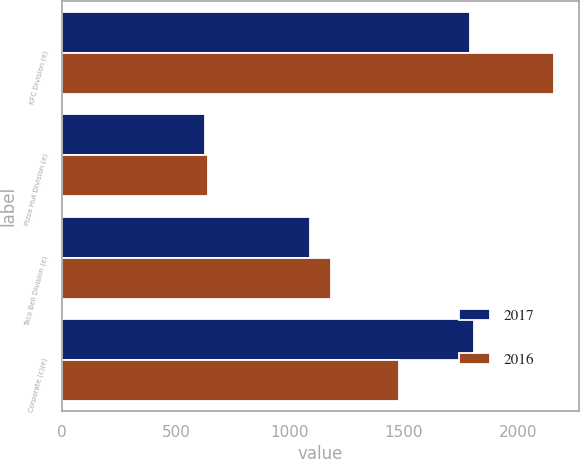Convert chart to OTSL. <chart><loc_0><loc_0><loc_500><loc_500><stacked_bar_chart><ecel><fcel>KFC Division (e)<fcel>Pizza Hut Division (e)<fcel>Taco Bell Division (e)<fcel>Corporate (c)(e)<nl><fcel>2017<fcel>1791<fcel>628<fcel>1086<fcel>1806<nl><fcel>2016<fcel>2158<fcel>639<fcel>1178<fcel>1478<nl></chart> 